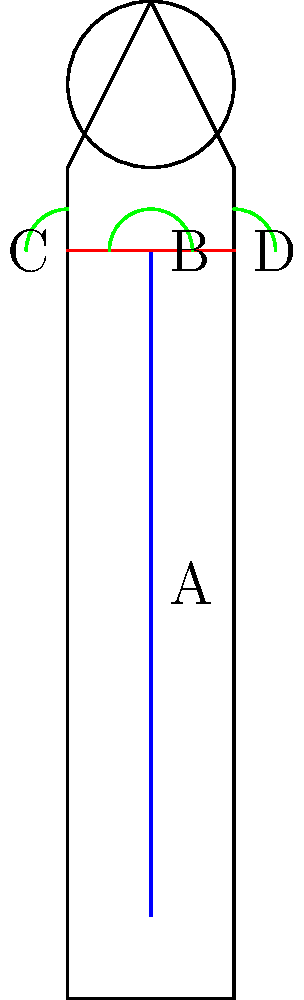In the skeletal diagram above, which angles should be maintained at approximately 90 degrees for proper posture during long filming sessions for child actors, and what potential issues might arise if these angles are not maintained? To understand proper posture for child actors during long filming sessions, we need to analyze the skeletal diagram and consider the biomechanical implications:

1. Spine curvature (A to B):
   - The natural S-curve of the spine should be maintained to distribute weight evenly.
   - If not maintained, it can lead to lower back pain and potential long-term spinal issues.

2. Neck position (top of B to head):
   - The head should be balanced on top of the spine, with ears aligned with the shoulders.
   - Improper neck position can cause neck strain and headaches.

3. Shoulder alignment (C to D):
   - Shoulders should be relaxed and level, forming a 90-degree angle with the upper arms when at rest.
   - Hunched or uneven shoulders can lead to muscle tension and potential postural deformities.

4. Hip angle:
   - While not explicitly shown in the diagram, the hips should form a 90-degree angle when seated.
   - Improper hip angle can cause lower back strain and affect overall posture.

5. Knee angle:
   - Also not shown, but knees should be at 90 degrees when seated.
   - Incorrect knee positioning can lead to circulation issues and leg discomfort.

The key 90-degree angles to maintain are:
a) The angle between the upper arm and torso at the shoulders (C and D)
b) The hip angle when seated
c) The knee angle when seated

Maintaining these angles helps distribute weight evenly, reduces muscle strain, and prevents long-term postural issues. For child actors, proper posture is especially crucial as their bodies are still developing, and poor habits can have lasting effects on their physical health and performance abilities.
Answer: Shoulder, hip, and knee angles at 90 degrees; prevents muscle strain and postural issues. 